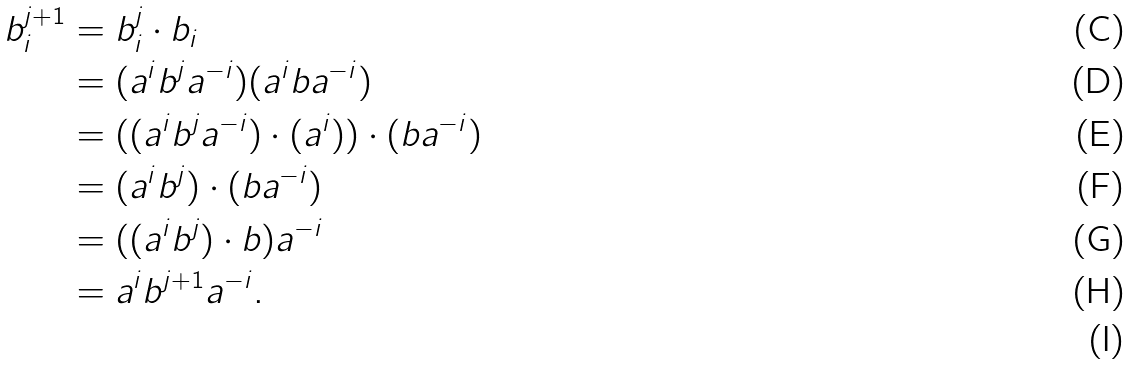<formula> <loc_0><loc_0><loc_500><loc_500>b _ { i } ^ { j + 1 } & = b _ { i } ^ { j } \cdot b _ { i } \\ & = ( a ^ { i } b ^ { j } a ^ { - i } ) ( a ^ { i } b a ^ { - i } ) \\ & = ( ( a ^ { i } b ^ { j } a ^ { - i } ) \cdot ( a ^ { i } ) ) \cdot ( b a ^ { - i } ) \\ & = ( a ^ { i } b ^ { j } ) \cdot ( b a ^ { - i } ) \\ & = ( ( a ^ { i } b ^ { j } ) \cdot b ) a ^ { - i } \\ & = a ^ { i } b ^ { j + 1 } a ^ { - i } . \\</formula> 